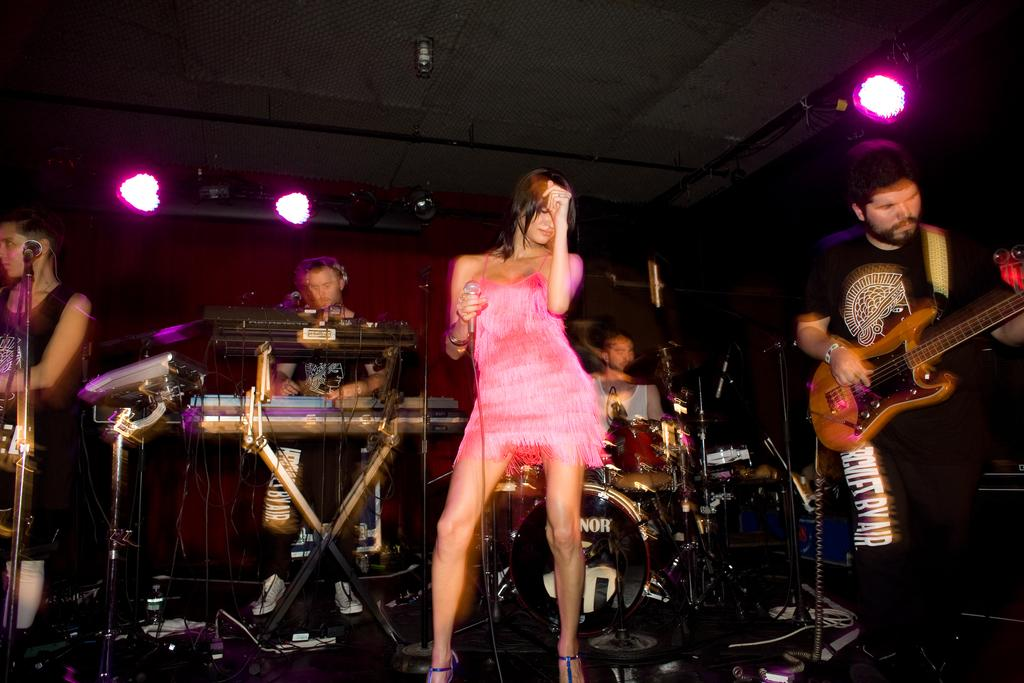What is the woman in the image doing? The woman is dancing in the image. What is the woman wearing while dancing? The woman is wearing a pink dress. What is the man in the image doing? The man is playing the guitar in the image. What can be seen at the top of the image? There are lights visible at the top of the image. What type of glue is being used by the bears in the image? There are no bears present in the image, and therefore no glue can be observed. 